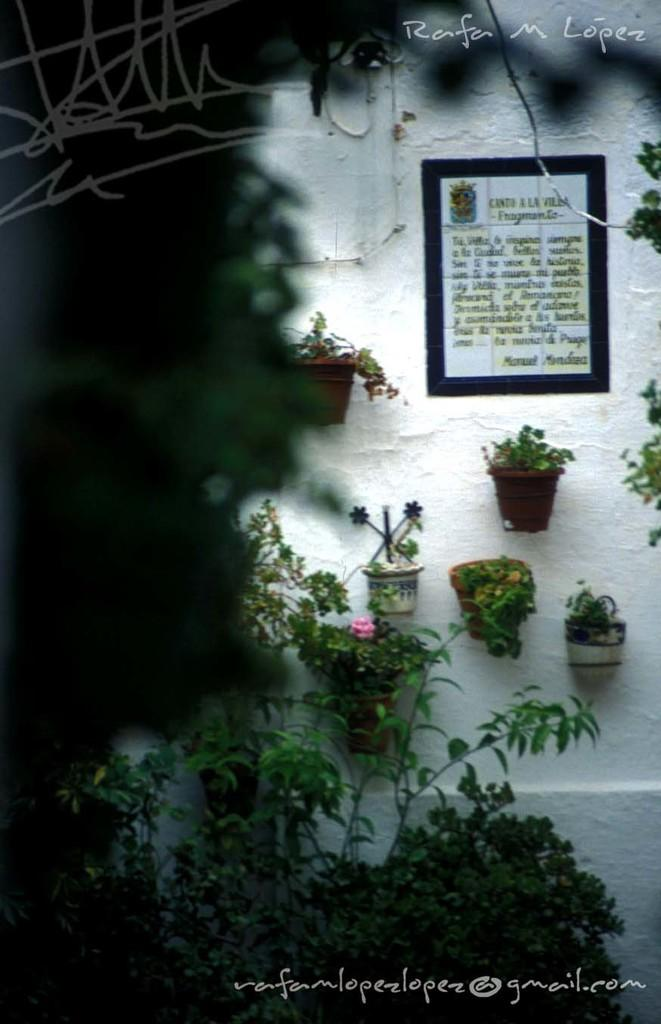What type of objects are in the flower pots in the image? There are plants in the flower pots in the image. What is attached to the wall in the image? A frame is attached to the wall in the image. Can you describe any marks or features on the image itself? There are watermarks at the top and bottom of the image. What type of verse can be seen written on the sidewalk in the image? There is no sidewalk or verse present in the image. What is the desire of the plants in the flower pots in the image? Plants do not have desires, so this question cannot be answered. 